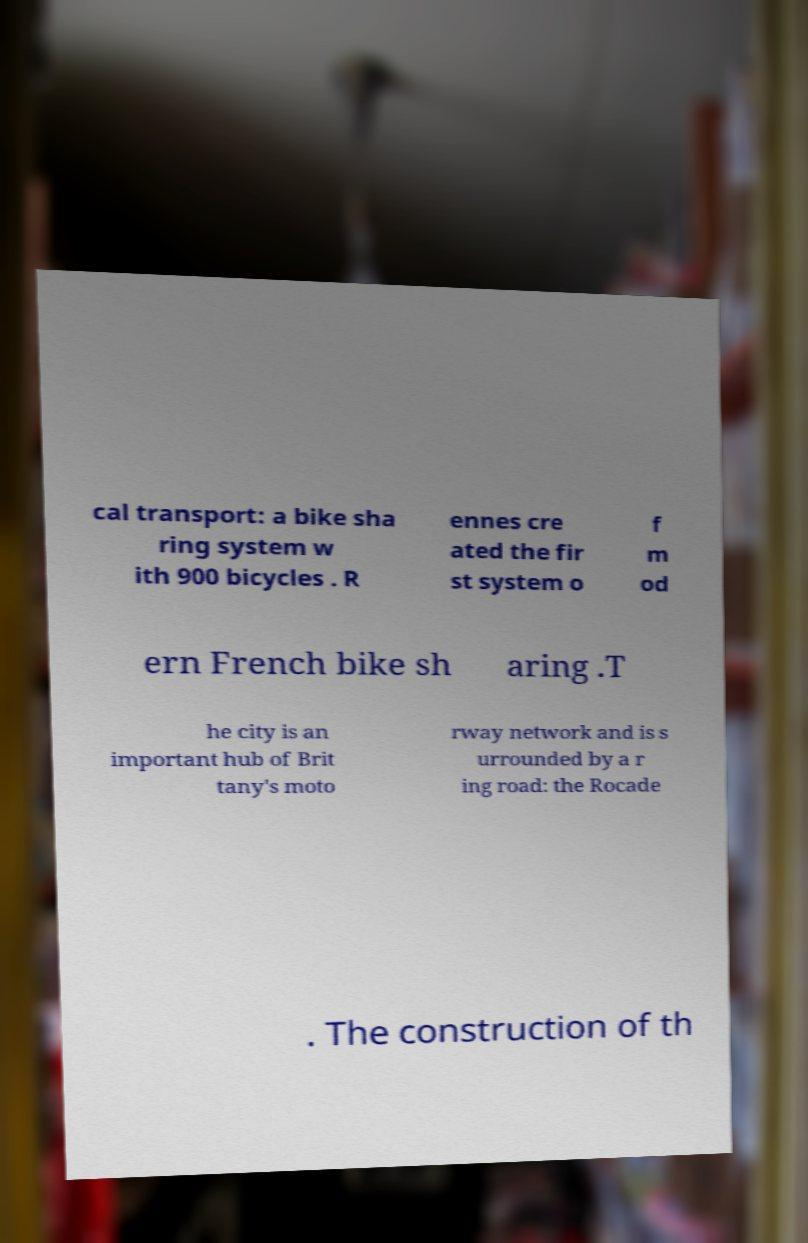Please identify and transcribe the text found in this image. cal transport: a bike sha ring system w ith 900 bicycles . R ennes cre ated the fir st system o f m od ern French bike sh aring .T he city is an important hub of Brit tany's moto rway network and is s urrounded by a r ing road: the Rocade . The construction of th 